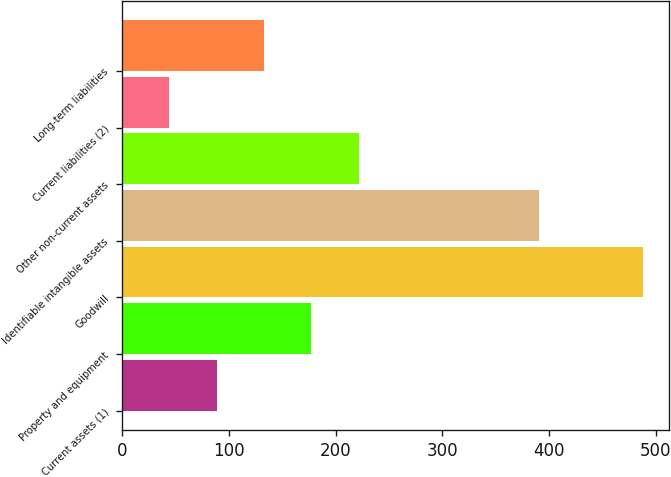Convert chart to OTSL. <chart><loc_0><loc_0><loc_500><loc_500><bar_chart><fcel>Current assets (1)<fcel>Property and equipment<fcel>Goodwill<fcel>Identifiable intangible assets<fcel>Other non-current assets<fcel>Current liabilities (2)<fcel>Long-term liabilities<nl><fcel>88.4<fcel>177.2<fcel>488<fcel>390<fcel>221.6<fcel>44<fcel>132.8<nl></chart> 